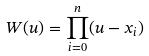<formula> <loc_0><loc_0><loc_500><loc_500>W ( u ) = \prod _ { i = 0 } ^ { n } ( u - x _ { i } )</formula> 